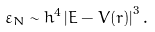Convert formula to latex. <formula><loc_0><loc_0><loc_500><loc_500>\varepsilon _ { N } \sim h ^ { 4 } \left | E - V ( r ) \right | ^ { 3 } .</formula> 